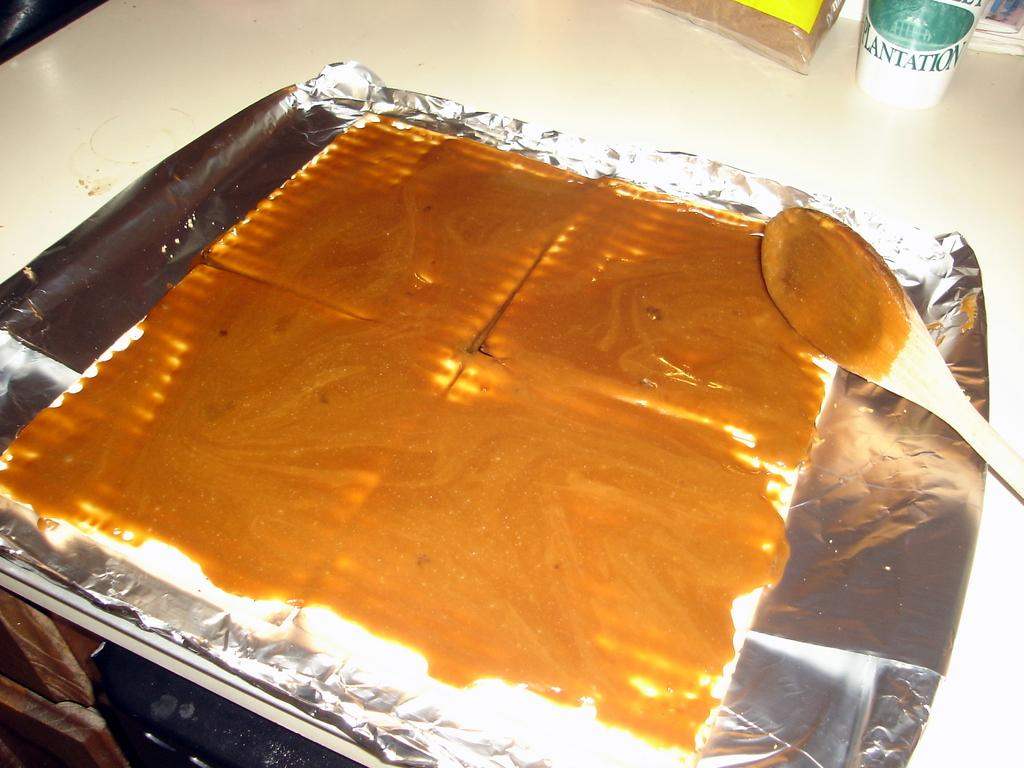<image>
Describe the image concisely. A can or bottle has a Plantation logo in green. 